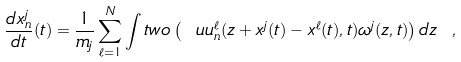<formula> <loc_0><loc_0><loc_500><loc_500>\frac { d x ^ { j } _ { n } } { d t } ( t ) = \frac { 1 } { m _ { j } } \sum _ { \ell = 1 } ^ { N } \int t w o \left ( \ u u ^ { \ell } _ { n } ( z + x ^ { j } ( t ) - x ^ { \ell } ( t ) , t ) \omega ^ { j } ( z , t ) \right ) d z \ ,</formula> 